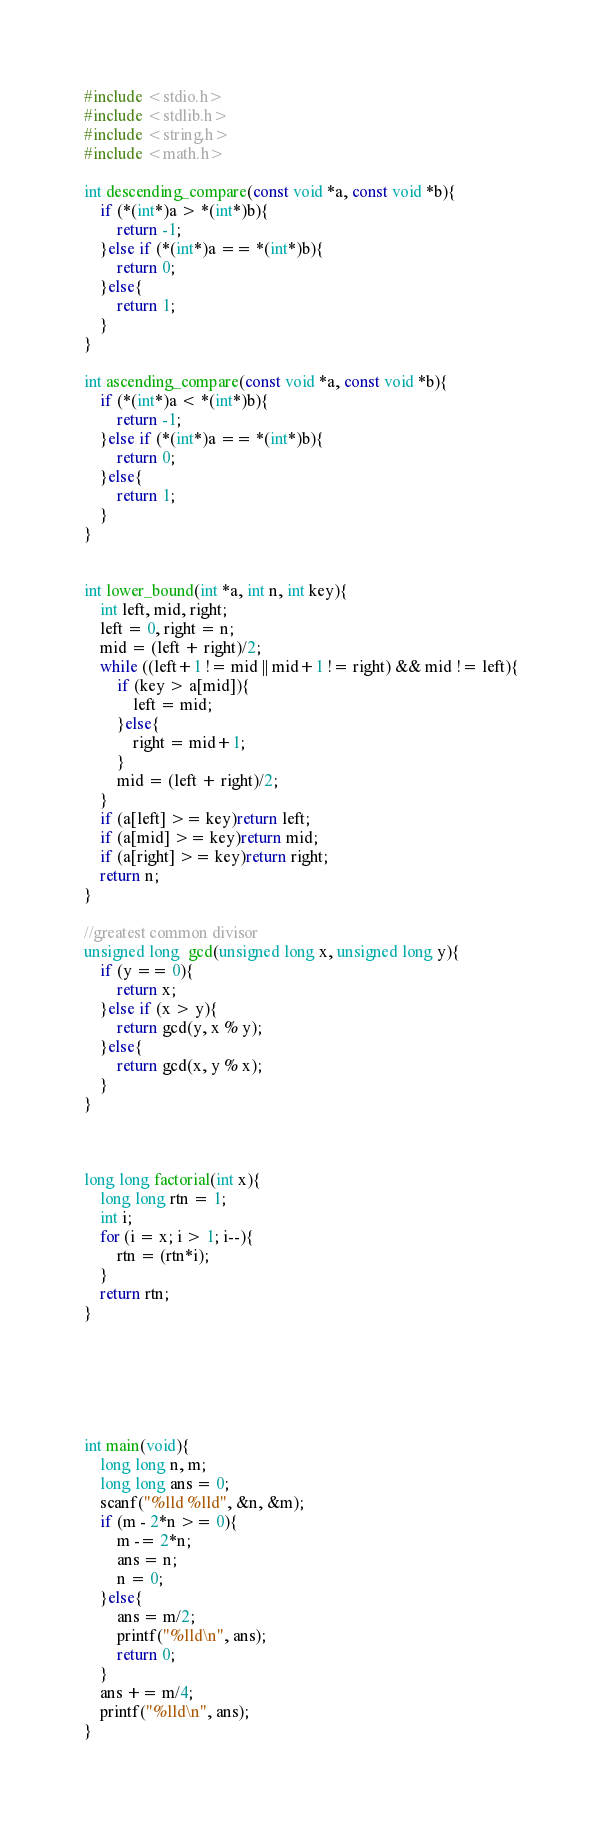<code> <loc_0><loc_0><loc_500><loc_500><_C_>#include <stdio.h>
#include <stdlib.h>
#include <string.h>
#include <math.h>

int descending_compare(const void *a, const void *b){
    if (*(int*)a > *(int*)b){
        return -1;
    }else if (*(int*)a == *(int*)b){
        return 0;
    }else{
        return 1;
    }
}

int ascending_compare(const void *a, const void *b){
    if (*(int*)a < *(int*)b){
        return -1;
    }else if (*(int*)a == *(int*)b){
        return 0;
    }else{
        return 1;
    }
}


int lower_bound(int *a, int n, int key){
    int left, mid, right;
    left = 0, right = n;
    mid = (left + right)/2;
    while ((left+1 != mid || mid+1 != right) && mid != left){
        if (key > a[mid]){
            left = mid;
        }else{
            right = mid+1;
        }
        mid = (left + right)/2;
    }
    if (a[left] >= key)return left;
    if (a[mid] >= key)return mid;
    if (a[right] >= key)return right;
    return n;
}

//greatest common divisor
unsigned long  gcd(unsigned long x, unsigned long y){
    if (y == 0){ 
        return x;
    }else if (x > y){
        return gcd(y, x % y);
    }else{
        return gcd(x, y % x);
    }
}



long long factorial(int x){
    long long rtn = 1;
    int i;
    for (i = x; i > 1; i--){
        rtn = (rtn*i);
    }
    return rtn;
}






int main(void){
    long long n, m;
    long long ans = 0;
    scanf("%lld %lld", &n, &m);
    if (m - 2*n >= 0){
        m -= 2*n; 
        ans = n;
        n = 0;
    }else{
        ans = m/2;
        printf("%lld\n", ans);
        return 0;
    }
    ans += m/4;
    printf("%lld\n", ans);
}
</code> 